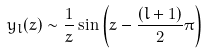<formula> <loc_0><loc_0><loc_500><loc_500>y _ { l } ( z ) \sim \frac { 1 } { z } \sin \left ( z - \frac { ( l + 1 ) } { 2 } \pi \right )</formula> 